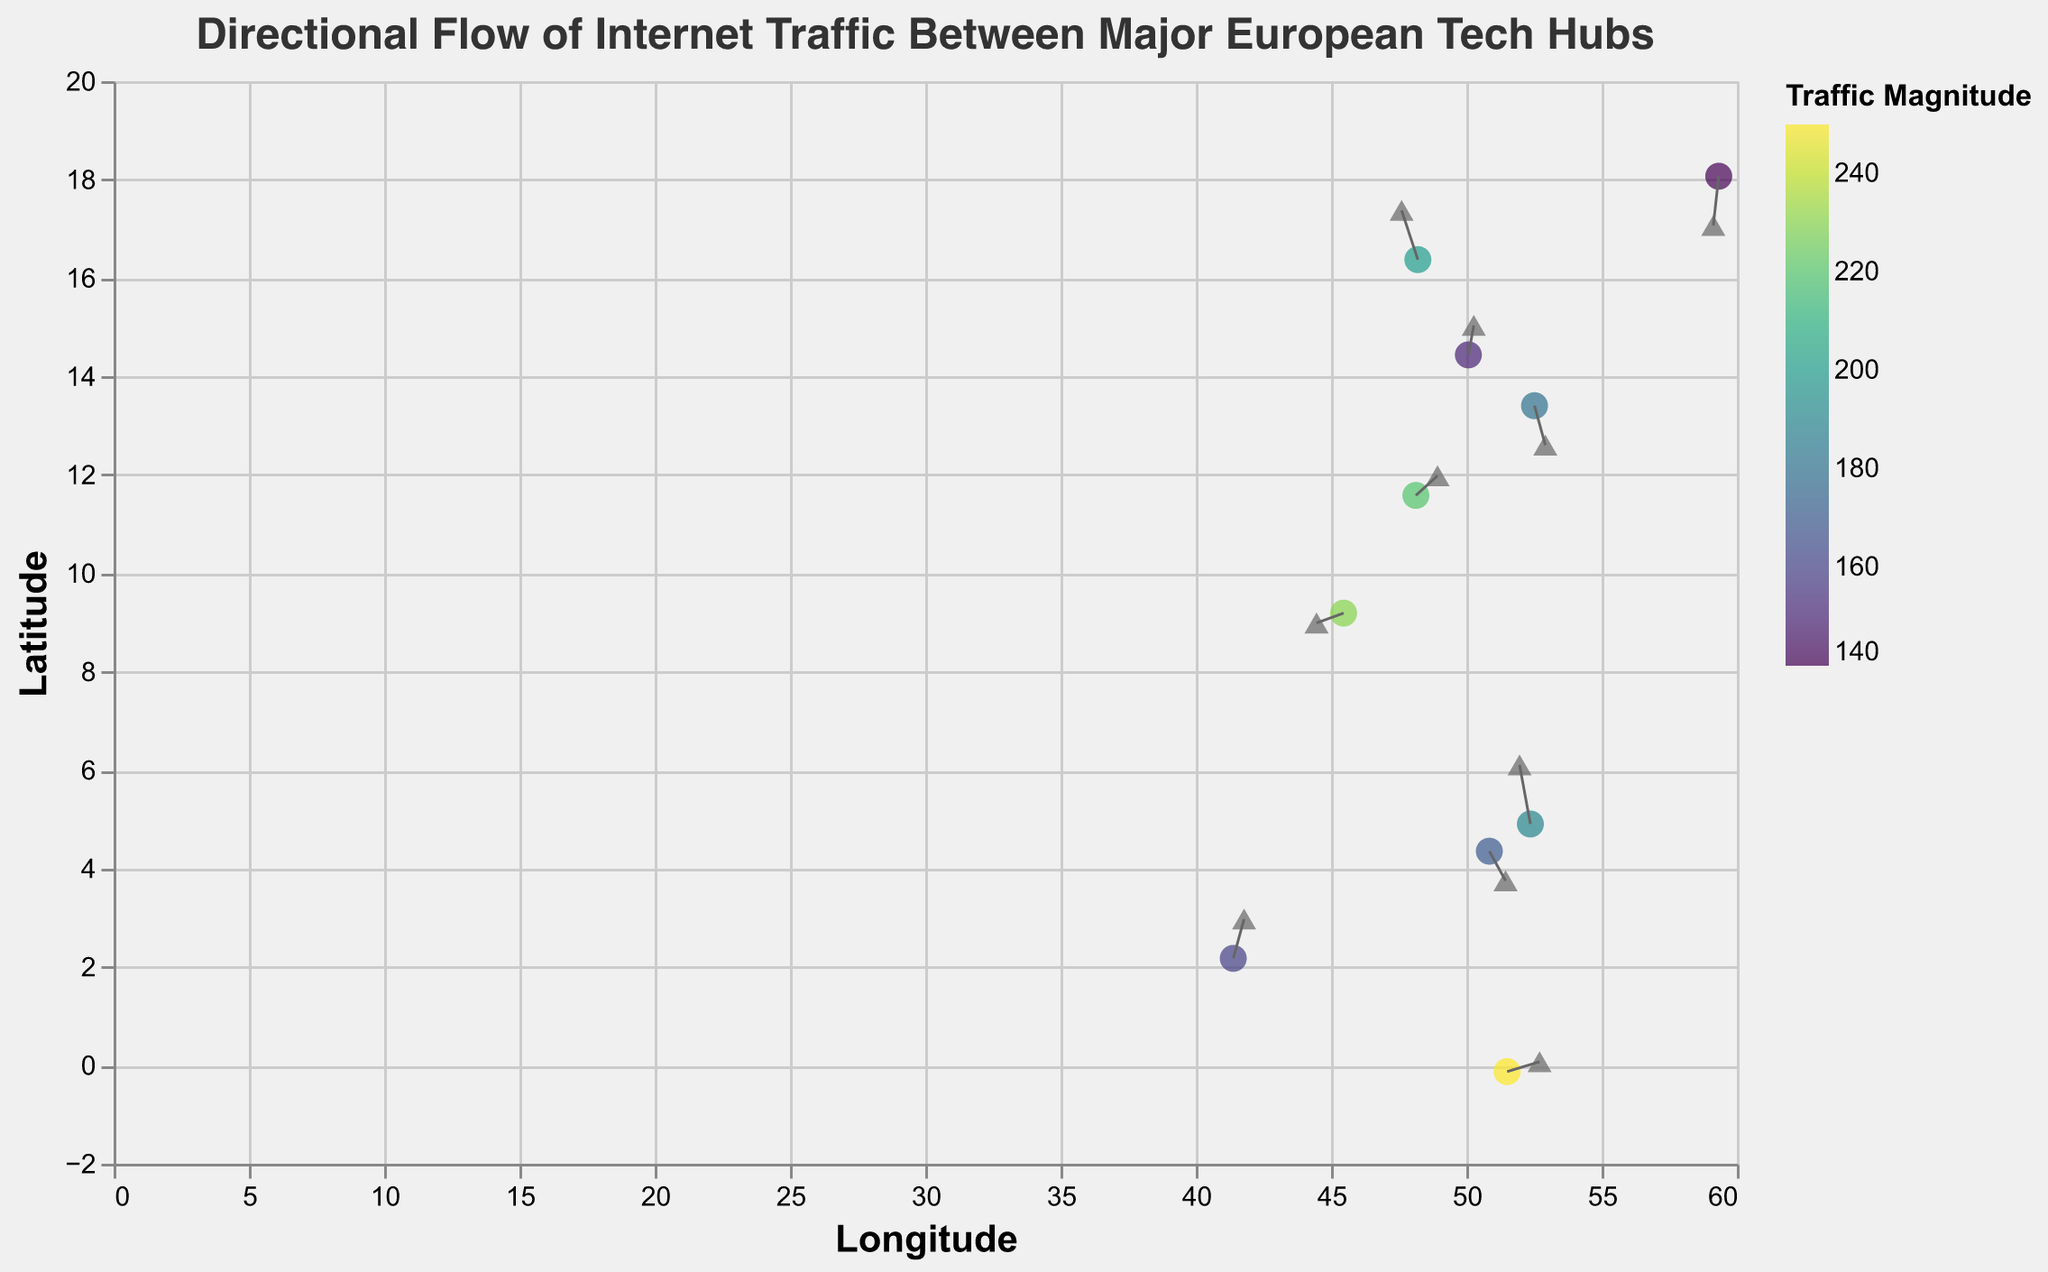What is the title of the figure? The title of the figure is usually found at the top of the chart and describes what the visualization is about. In this case, it's "Directional Flow of Internet Traffic Between Major European Tech Hubs".
Answer: Directional Flow of Internet Traffic Between Major European Tech Hubs How many major European tech hubs are represented in the figure? Count the number of individual data points (marked as circles). According to the data, there are 10 data points.
Answer: 10 Which city has the highest magnitude of internet traffic? The magnitude is represented by the color of the points. By checking the data, London (with coordinates 51.5074, -0.1278) has the highest magnitude of 250.
Answer: London What are the longitude and latitude axes representative of in the figure? The x-axis represents the longitude, and the y-axis represents the latitude, as indicated by the axis titles in the figure.
Answer: Longitude and Latitude What direction does the internet traffic flow from Milan (45.4642, 9.1900)? For Milan (coordinates 45.4642, 9.1900), u is -0.5 and v is -0.1. This indicates traffic flow towards the west (negative x direction) and slightly towards the south (negative y direction).
Answer: West and slightly south Which tech hub experiences internet traffic flowing in the southwestern direction? Stockholm (coordinates 59.3293, 18.0686) has u as -0.1 and v as -0.5. This means the traffic flows towards the southwest (negative x and y direction).
Answer: Stockholm Between Berlin (52.5200, 13.4050) and Munich (48.1351, 11.5820), which tech hub has a higher magnitude of internet traffic? According to the data provided, Berlin has a magnitude of 180, while Munich has a magnitude of 220. Thus, Munich has a higher magnitude of internet traffic.
Answer: Munich What is the sum of internet traffic magnitudes for all tech hubs combined? Sum all the magnitudes given in the data: 200 + 180 + 150 + 220 + 190 + 170 + 230 + 160 + 250 + 140 = 1890.
Answer: 1890 Which city has the least internet traffic flow magnitude? The city with the lowest magnitude based on the data provided is Stockholm (coordinates 59.3293, 18.0686) with a magnitude of 140.
Answer: Stockholm How does the traffic flow at Amsterdam (52.3676, 4.9041) compare in direction to Berlin (52.5200, 13.4050)? Amsterdam has u as -0.2 and v as 0.6 indicating a north-west direction, while Berlin has u as 0.2 and v as -0.4 indicating a south-east direction. Thus, their flow directions are almost opposite.
Answer: Opposite Directions 